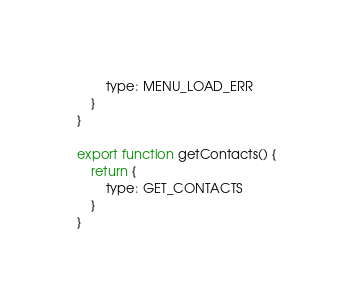<code> <loc_0><loc_0><loc_500><loc_500><_JavaScript_>		type: MENU_LOAD_ERR
	}
}

export function getContacts() {
	return {
		type: GET_CONTACTS
	}
}</code> 